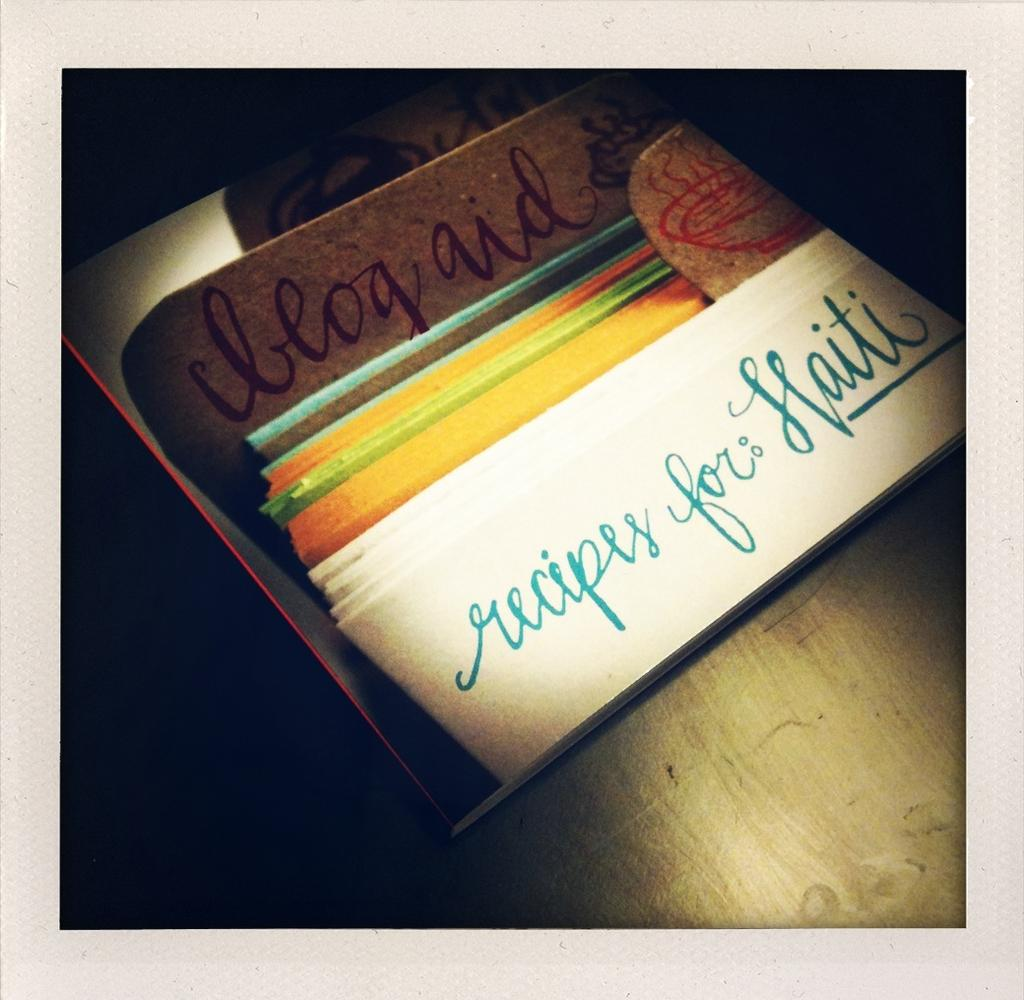<image>
Provide a brief description of the given image. A book about recipes for Haiti sits on a table in a darkened room. 